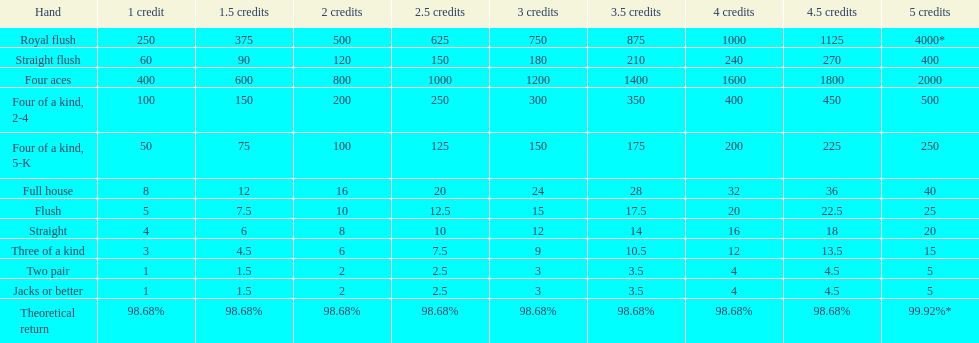Is four 5s worth more or less than four 2s? Less. 